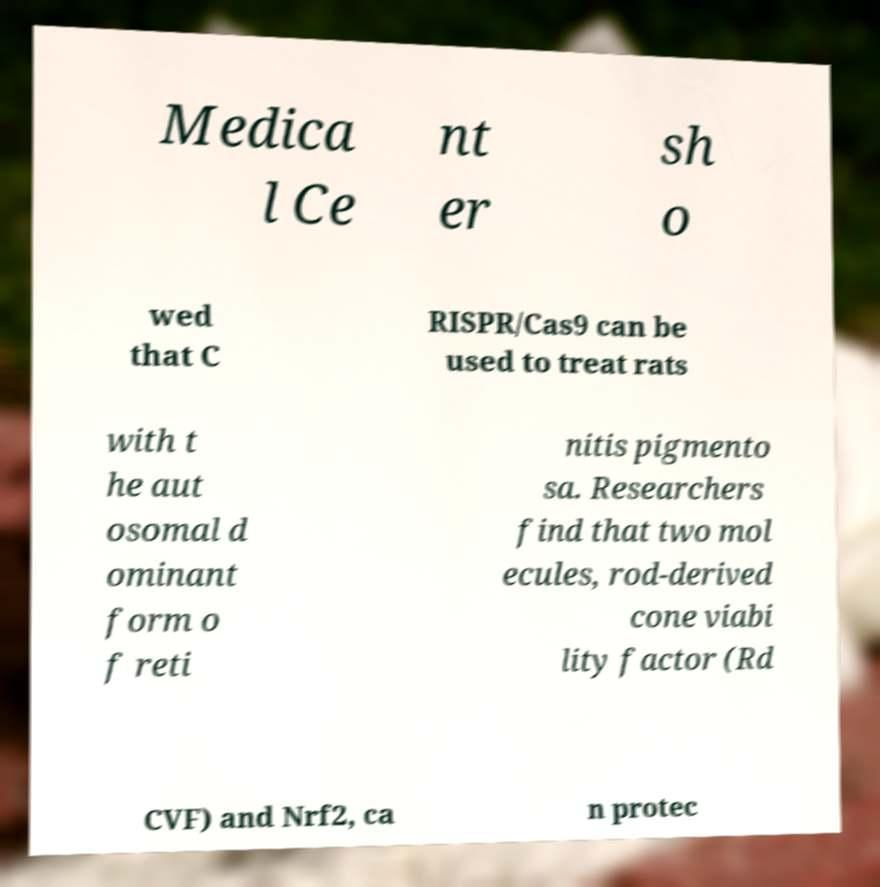What messages or text are displayed in this image? I need them in a readable, typed format. Medica l Ce nt er sh o wed that C RISPR/Cas9 can be used to treat rats with t he aut osomal d ominant form o f reti nitis pigmento sa. Researchers find that two mol ecules, rod-derived cone viabi lity factor (Rd CVF) and Nrf2, ca n protec 